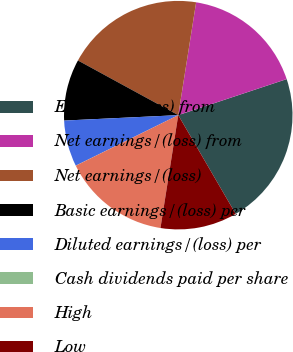Convert chart to OTSL. <chart><loc_0><loc_0><loc_500><loc_500><pie_chart><fcel>Earnings/(loss) from<fcel>Net earnings/(loss) from<fcel>Net earnings/(loss)<fcel>Basic earnings/(loss) per<fcel>Diluted earnings/(loss) per<fcel>Cash dividends paid per share<fcel>High<fcel>Low<nl><fcel>21.73%<fcel>17.39%<fcel>19.56%<fcel>8.7%<fcel>6.53%<fcel>0.01%<fcel>15.22%<fcel>10.87%<nl></chart> 